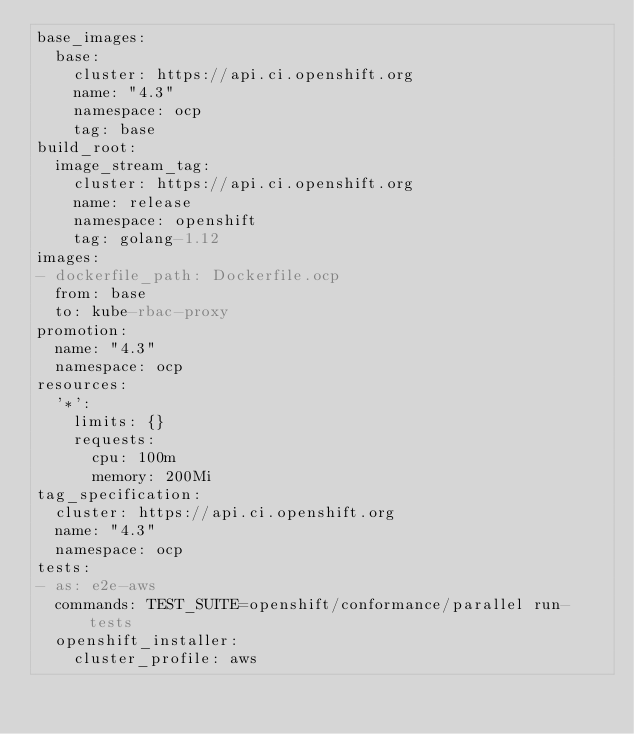<code> <loc_0><loc_0><loc_500><loc_500><_YAML_>base_images:
  base:
    cluster: https://api.ci.openshift.org
    name: "4.3"
    namespace: ocp
    tag: base
build_root:
  image_stream_tag:
    cluster: https://api.ci.openshift.org
    name: release
    namespace: openshift
    tag: golang-1.12
images:
- dockerfile_path: Dockerfile.ocp
  from: base
  to: kube-rbac-proxy
promotion:
  name: "4.3"
  namespace: ocp
resources:
  '*':
    limits: {}
    requests:
      cpu: 100m
      memory: 200Mi
tag_specification:
  cluster: https://api.ci.openshift.org
  name: "4.3"
  namespace: ocp
tests:
- as: e2e-aws
  commands: TEST_SUITE=openshift/conformance/parallel run-tests
  openshift_installer:
    cluster_profile: aws
</code> 